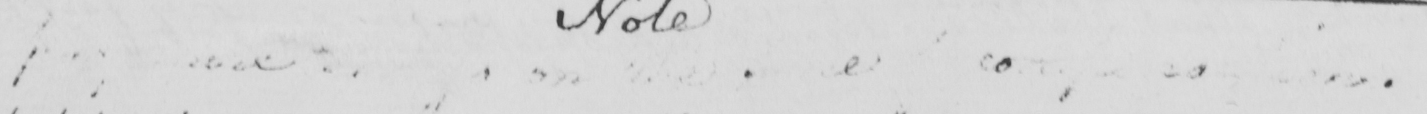Please transcribe the handwritten text in this image. <gap/>  <gap/>  <gap/>  <gap/>  <gap/> 